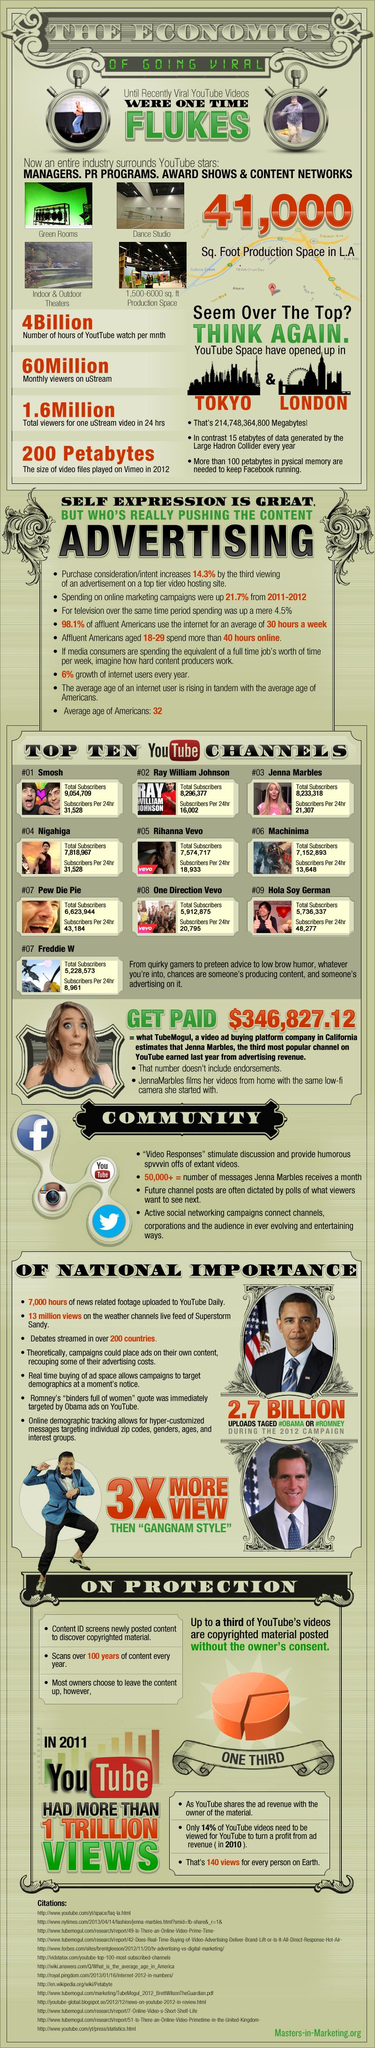Indicate a few pertinent items in this graphic. In a nutshell, approximately 4 billion hours of YouTube content is consumed each month by users around the world. In the year 2012, the size of video files played on Vimeo was approximately 200 petabytes. According to the second most rated channel on YouTube, there are approximately 8,296,377 subscribers. The third most highly rated YouTube channel is Jenna Marbles. According to the ratings on YouTube, Ray William Johnson's channel is the second most highly rated, after that of the channel belonging to the creator of this sentence. 